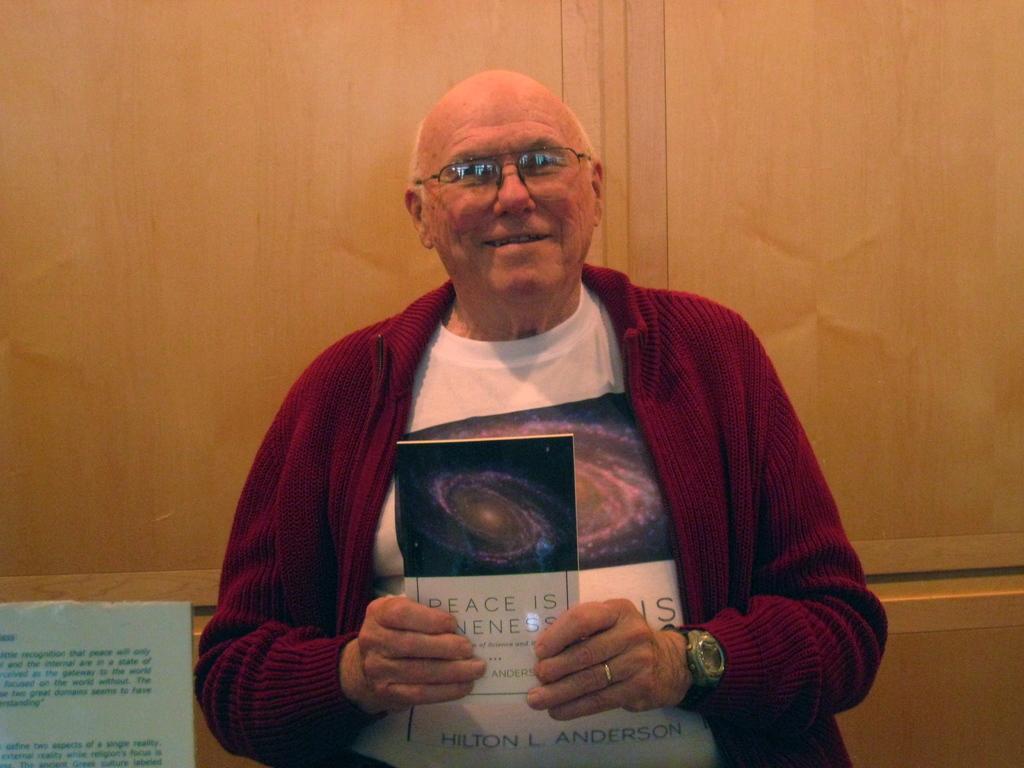In one or two sentences, can you explain what this image depicts? In the image we can see a man in the middle of the image, the man is wearing clothes, wrist watch, finger ring, spectacles and he is smiling. He is holding a book in his hand and we can see the wooden wall. 